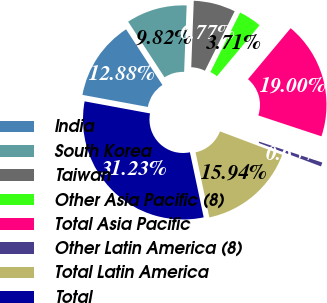Convert chart to OTSL. <chart><loc_0><loc_0><loc_500><loc_500><pie_chart><fcel>India<fcel>South Korea<fcel>Taiwan<fcel>Other Asia Pacific (8)<fcel>Total Asia Pacific<fcel>Other Latin America (8)<fcel>Total Latin America<fcel>Total<nl><fcel>12.88%<fcel>9.82%<fcel>6.77%<fcel>3.71%<fcel>19.0%<fcel>0.65%<fcel>15.94%<fcel>31.23%<nl></chart> 